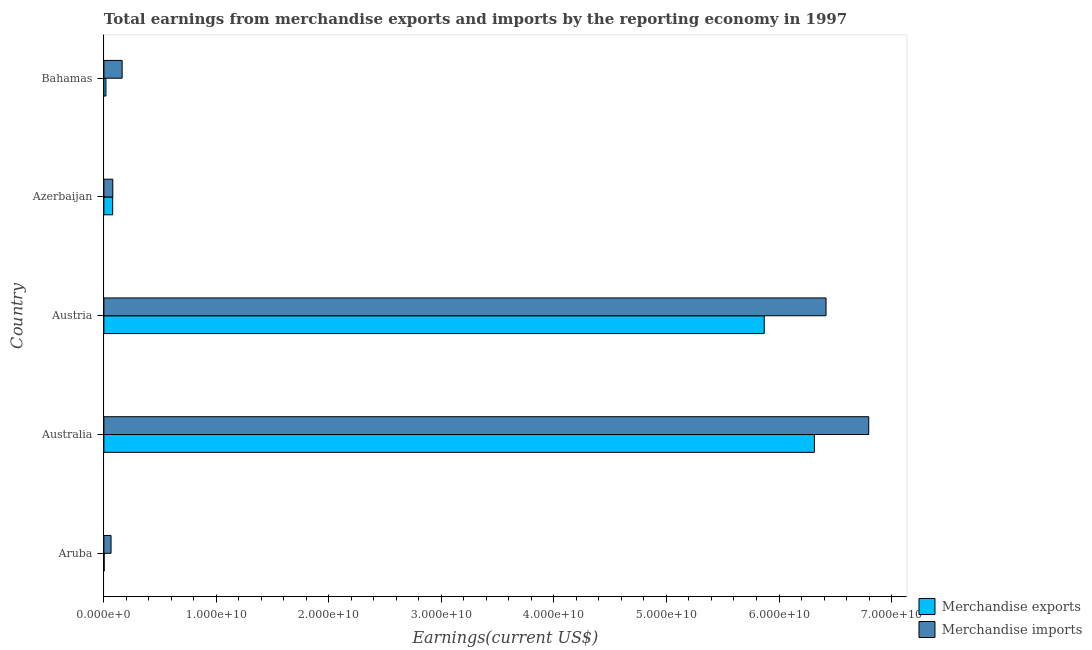How many different coloured bars are there?
Offer a terse response. 2. How many groups of bars are there?
Your answer should be very brief. 5. Are the number of bars per tick equal to the number of legend labels?
Give a very brief answer. Yes. What is the label of the 3rd group of bars from the top?
Offer a terse response. Austria. In how many cases, is the number of bars for a given country not equal to the number of legend labels?
Provide a succinct answer. 0. What is the earnings from merchandise imports in Bahamas?
Provide a short and direct response. 1.62e+09. Across all countries, what is the maximum earnings from merchandise imports?
Provide a succinct answer. 6.80e+1. Across all countries, what is the minimum earnings from merchandise exports?
Your answer should be compact. 2.39e+07. In which country was the earnings from merchandise imports maximum?
Your answer should be very brief. Australia. In which country was the earnings from merchandise exports minimum?
Your answer should be compact. Aruba. What is the total earnings from merchandise exports in the graph?
Your answer should be very brief. 1.23e+11. What is the difference between the earnings from merchandise imports in Australia and that in Azerbaijan?
Ensure brevity in your answer.  6.72e+1. What is the difference between the earnings from merchandise exports in Bahamas and the earnings from merchandise imports in Aruba?
Provide a short and direct response. -4.54e+08. What is the average earnings from merchandise imports per country?
Provide a short and direct response. 2.70e+1. What is the difference between the earnings from merchandise imports and earnings from merchandise exports in Austria?
Offer a terse response. 5.49e+09. What is the ratio of the earnings from merchandise exports in Aruba to that in Australia?
Offer a very short reply. 0. Is the earnings from merchandise imports in Australia less than that in Bahamas?
Ensure brevity in your answer.  No. Is the difference between the earnings from merchandise exports in Austria and Azerbaijan greater than the difference between the earnings from merchandise imports in Austria and Azerbaijan?
Your answer should be very brief. No. What is the difference between the highest and the second highest earnings from merchandise imports?
Provide a succinct answer. 3.79e+09. What is the difference between the highest and the lowest earnings from merchandise exports?
Ensure brevity in your answer.  6.31e+1. In how many countries, is the earnings from merchandise exports greater than the average earnings from merchandise exports taken over all countries?
Provide a succinct answer. 2. Is the sum of the earnings from merchandise imports in Aruba and Australia greater than the maximum earnings from merchandise exports across all countries?
Keep it short and to the point. Yes. What does the 2nd bar from the top in Austria represents?
Your answer should be very brief. Merchandise exports. What is the difference between two consecutive major ticks on the X-axis?
Your answer should be very brief. 1.00e+1. Are the values on the major ticks of X-axis written in scientific E-notation?
Your answer should be compact. Yes. Does the graph contain any zero values?
Ensure brevity in your answer.  No. What is the title of the graph?
Your response must be concise. Total earnings from merchandise exports and imports by the reporting economy in 1997. What is the label or title of the X-axis?
Provide a short and direct response. Earnings(current US$). What is the label or title of the Y-axis?
Give a very brief answer. Country. What is the Earnings(current US$) of Merchandise exports in Aruba?
Offer a terse response. 2.39e+07. What is the Earnings(current US$) in Merchandise imports in Aruba?
Provide a succinct answer. 6.35e+08. What is the Earnings(current US$) of Merchandise exports in Australia?
Your answer should be compact. 6.31e+1. What is the Earnings(current US$) in Merchandise imports in Australia?
Offer a very short reply. 6.80e+1. What is the Earnings(current US$) in Merchandise exports in Austria?
Offer a very short reply. 5.87e+1. What is the Earnings(current US$) of Merchandise imports in Austria?
Your answer should be very brief. 6.42e+1. What is the Earnings(current US$) in Merchandise exports in Azerbaijan?
Your response must be concise. 7.81e+08. What is the Earnings(current US$) of Merchandise imports in Azerbaijan?
Your answer should be compact. 7.91e+08. What is the Earnings(current US$) in Merchandise exports in Bahamas?
Offer a terse response. 1.81e+08. What is the Earnings(current US$) of Merchandise imports in Bahamas?
Your response must be concise. 1.62e+09. Across all countries, what is the maximum Earnings(current US$) in Merchandise exports?
Offer a terse response. 6.31e+1. Across all countries, what is the maximum Earnings(current US$) of Merchandise imports?
Your answer should be very brief. 6.80e+1. Across all countries, what is the minimum Earnings(current US$) of Merchandise exports?
Provide a short and direct response. 2.39e+07. Across all countries, what is the minimum Earnings(current US$) in Merchandise imports?
Ensure brevity in your answer.  6.35e+08. What is the total Earnings(current US$) of Merchandise exports in the graph?
Provide a short and direct response. 1.23e+11. What is the total Earnings(current US$) in Merchandise imports in the graph?
Your response must be concise. 1.35e+11. What is the difference between the Earnings(current US$) of Merchandise exports in Aruba and that in Australia?
Provide a succinct answer. -6.31e+1. What is the difference between the Earnings(current US$) in Merchandise imports in Aruba and that in Australia?
Your response must be concise. -6.73e+1. What is the difference between the Earnings(current US$) of Merchandise exports in Aruba and that in Austria?
Keep it short and to the point. -5.87e+1. What is the difference between the Earnings(current US$) of Merchandise imports in Aruba and that in Austria?
Offer a very short reply. -6.35e+1. What is the difference between the Earnings(current US$) in Merchandise exports in Aruba and that in Azerbaijan?
Provide a short and direct response. -7.57e+08. What is the difference between the Earnings(current US$) in Merchandise imports in Aruba and that in Azerbaijan?
Ensure brevity in your answer.  -1.56e+08. What is the difference between the Earnings(current US$) of Merchandise exports in Aruba and that in Bahamas?
Provide a succinct answer. -1.57e+08. What is the difference between the Earnings(current US$) of Merchandise imports in Aruba and that in Bahamas?
Your answer should be compact. -9.86e+08. What is the difference between the Earnings(current US$) of Merchandise exports in Australia and that in Austria?
Offer a terse response. 4.46e+09. What is the difference between the Earnings(current US$) in Merchandise imports in Australia and that in Austria?
Keep it short and to the point. 3.79e+09. What is the difference between the Earnings(current US$) in Merchandise exports in Australia and that in Azerbaijan?
Provide a succinct answer. 6.24e+1. What is the difference between the Earnings(current US$) in Merchandise imports in Australia and that in Azerbaijan?
Your answer should be very brief. 6.72e+1. What is the difference between the Earnings(current US$) of Merchandise exports in Australia and that in Bahamas?
Make the answer very short. 6.30e+1. What is the difference between the Earnings(current US$) of Merchandise imports in Australia and that in Bahamas?
Make the answer very short. 6.64e+1. What is the difference between the Earnings(current US$) of Merchandise exports in Austria and that in Azerbaijan?
Provide a short and direct response. 5.79e+1. What is the difference between the Earnings(current US$) in Merchandise imports in Austria and that in Azerbaijan?
Ensure brevity in your answer.  6.34e+1. What is the difference between the Earnings(current US$) of Merchandise exports in Austria and that in Bahamas?
Your answer should be compact. 5.85e+1. What is the difference between the Earnings(current US$) in Merchandise imports in Austria and that in Bahamas?
Offer a terse response. 6.26e+1. What is the difference between the Earnings(current US$) of Merchandise exports in Azerbaijan and that in Bahamas?
Your answer should be compact. 6.00e+08. What is the difference between the Earnings(current US$) in Merchandise imports in Azerbaijan and that in Bahamas?
Offer a very short reply. -8.30e+08. What is the difference between the Earnings(current US$) in Merchandise exports in Aruba and the Earnings(current US$) in Merchandise imports in Australia?
Give a very brief answer. -6.80e+1. What is the difference between the Earnings(current US$) in Merchandise exports in Aruba and the Earnings(current US$) in Merchandise imports in Austria?
Your answer should be compact. -6.42e+1. What is the difference between the Earnings(current US$) of Merchandise exports in Aruba and the Earnings(current US$) of Merchandise imports in Azerbaijan?
Keep it short and to the point. -7.68e+08. What is the difference between the Earnings(current US$) of Merchandise exports in Aruba and the Earnings(current US$) of Merchandise imports in Bahamas?
Ensure brevity in your answer.  -1.60e+09. What is the difference between the Earnings(current US$) of Merchandise exports in Australia and the Earnings(current US$) of Merchandise imports in Austria?
Your answer should be very brief. -1.03e+09. What is the difference between the Earnings(current US$) of Merchandise exports in Australia and the Earnings(current US$) of Merchandise imports in Azerbaijan?
Make the answer very short. 6.24e+1. What is the difference between the Earnings(current US$) of Merchandise exports in Australia and the Earnings(current US$) of Merchandise imports in Bahamas?
Your answer should be very brief. 6.15e+1. What is the difference between the Earnings(current US$) of Merchandise exports in Austria and the Earnings(current US$) of Merchandise imports in Azerbaijan?
Keep it short and to the point. 5.79e+1. What is the difference between the Earnings(current US$) in Merchandise exports in Austria and the Earnings(current US$) in Merchandise imports in Bahamas?
Make the answer very short. 5.71e+1. What is the difference between the Earnings(current US$) in Merchandise exports in Azerbaijan and the Earnings(current US$) in Merchandise imports in Bahamas?
Your response must be concise. -8.40e+08. What is the average Earnings(current US$) of Merchandise exports per country?
Make the answer very short. 2.46e+1. What is the average Earnings(current US$) of Merchandise imports per country?
Your answer should be compact. 2.70e+1. What is the difference between the Earnings(current US$) in Merchandise exports and Earnings(current US$) in Merchandise imports in Aruba?
Give a very brief answer. -6.11e+08. What is the difference between the Earnings(current US$) of Merchandise exports and Earnings(current US$) of Merchandise imports in Australia?
Your answer should be very brief. -4.83e+09. What is the difference between the Earnings(current US$) in Merchandise exports and Earnings(current US$) in Merchandise imports in Austria?
Provide a short and direct response. -5.49e+09. What is the difference between the Earnings(current US$) of Merchandise exports and Earnings(current US$) of Merchandise imports in Azerbaijan?
Provide a succinct answer. -1.02e+07. What is the difference between the Earnings(current US$) of Merchandise exports and Earnings(current US$) of Merchandise imports in Bahamas?
Your answer should be compact. -1.44e+09. What is the ratio of the Earnings(current US$) in Merchandise exports in Aruba to that in Australia?
Offer a terse response. 0. What is the ratio of the Earnings(current US$) of Merchandise imports in Aruba to that in Australia?
Give a very brief answer. 0.01. What is the ratio of the Earnings(current US$) of Merchandise exports in Aruba to that in Austria?
Offer a terse response. 0. What is the ratio of the Earnings(current US$) of Merchandise imports in Aruba to that in Austria?
Keep it short and to the point. 0.01. What is the ratio of the Earnings(current US$) of Merchandise exports in Aruba to that in Azerbaijan?
Your answer should be very brief. 0.03. What is the ratio of the Earnings(current US$) of Merchandise imports in Aruba to that in Azerbaijan?
Ensure brevity in your answer.  0.8. What is the ratio of the Earnings(current US$) in Merchandise exports in Aruba to that in Bahamas?
Make the answer very short. 0.13. What is the ratio of the Earnings(current US$) in Merchandise imports in Aruba to that in Bahamas?
Make the answer very short. 0.39. What is the ratio of the Earnings(current US$) of Merchandise exports in Australia to that in Austria?
Provide a succinct answer. 1.08. What is the ratio of the Earnings(current US$) in Merchandise imports in Australia to that in Austria?
Provide a short and direct response. 1.06. What is the ratio of the Earnings(current US$) of Merchandise exports in Australia to that in Azerbaijan?
Offer a terse response. 80.82. What is the ratio of the Earnings(current US$) of Merchandise imports in Australia to that in Azerbaijan?
Keep it short and to the point. 85.88. What is the ratio of the Earnings(current US$) of Merchandise exports in Australia to that in Bahamas?
Provide a short and direct response. 348.14. What is the ratio of the Earnings(current US$) in Merchandise imports in Australia to that in Bahamas?
Your answer should be very brief. 41.92. What is the ratio of the Earnings(current US$) of Merchandise exports in Austria to that in Azerbaijan?
Keep it short and to the point. 75.12. What is the ratio of the Earnings(current US$) of Merchandise imports in Austria to that in Azerbaijan?
Provide a short and direct response. 81.09. What is the ratio of the Earnings(current US$) in Merchandise exports in Austria to that in Bahamas?
Your answer should be compact. 323.57. What is the ratio of the Earnings(current US$) in Merchandise imports in Austria to that in Bahamas?
Offer a very short reply. 39.58. What is the ratio of the Earnings(current US$) of Merchandise exports in Azerbaijan to that in Bahamas?
Your response must be concise. 4.31. What is the ratio of the Earnings(current US$) in Merchandise imports in Azerbaijan to that in Bahamas?
Offer a very short reply. 0.49. What is the difference between the highest and the second highest Earnings(current US$) of Merchandise exports?
Keep it short and to the point. 4.46e+09. What is the difference between the highest and the second highest Earnings(current US$) in Merchandise imports?
Your answer should be compact. 3.79e+09. What is the difference between the highest and the lowest Earnings(current US$) of Merchandise exports?
Keep it short and to the point. 6.31e+1. What is the difference between the highest and the lowest Earnings(current US$) in Merchandise imports?
Provide a succinct answer. 6.73e+1. 